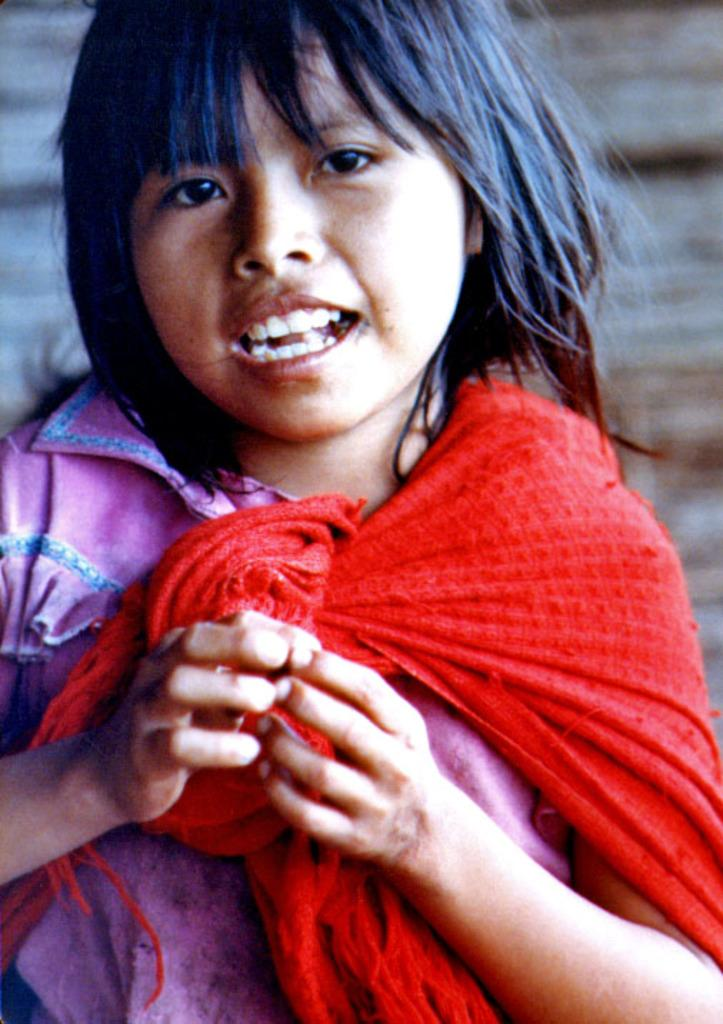Who is the main subject in the picture? There is a girl in the picture. What is the girl doing in the image? The girl appears to be speaking. What is the girl wearing in the image? The girl is wearing a pink dress. Can you describe any other objects or colors in the image? There is a red-colored cloth in the image. What type of bread is being used to cover the girl's face in the image? There is no bread present in the image, and the girl's face is not covered. 